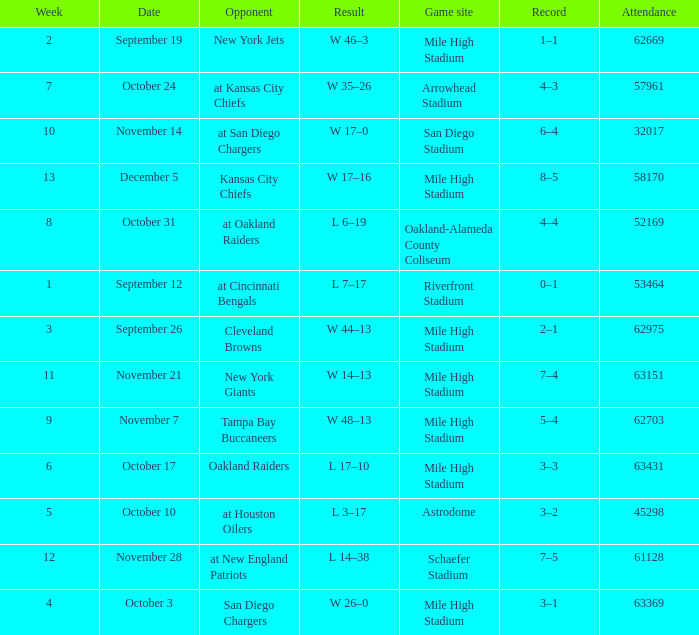What was the week number when the opponent was the New York Jets? 2.0. 